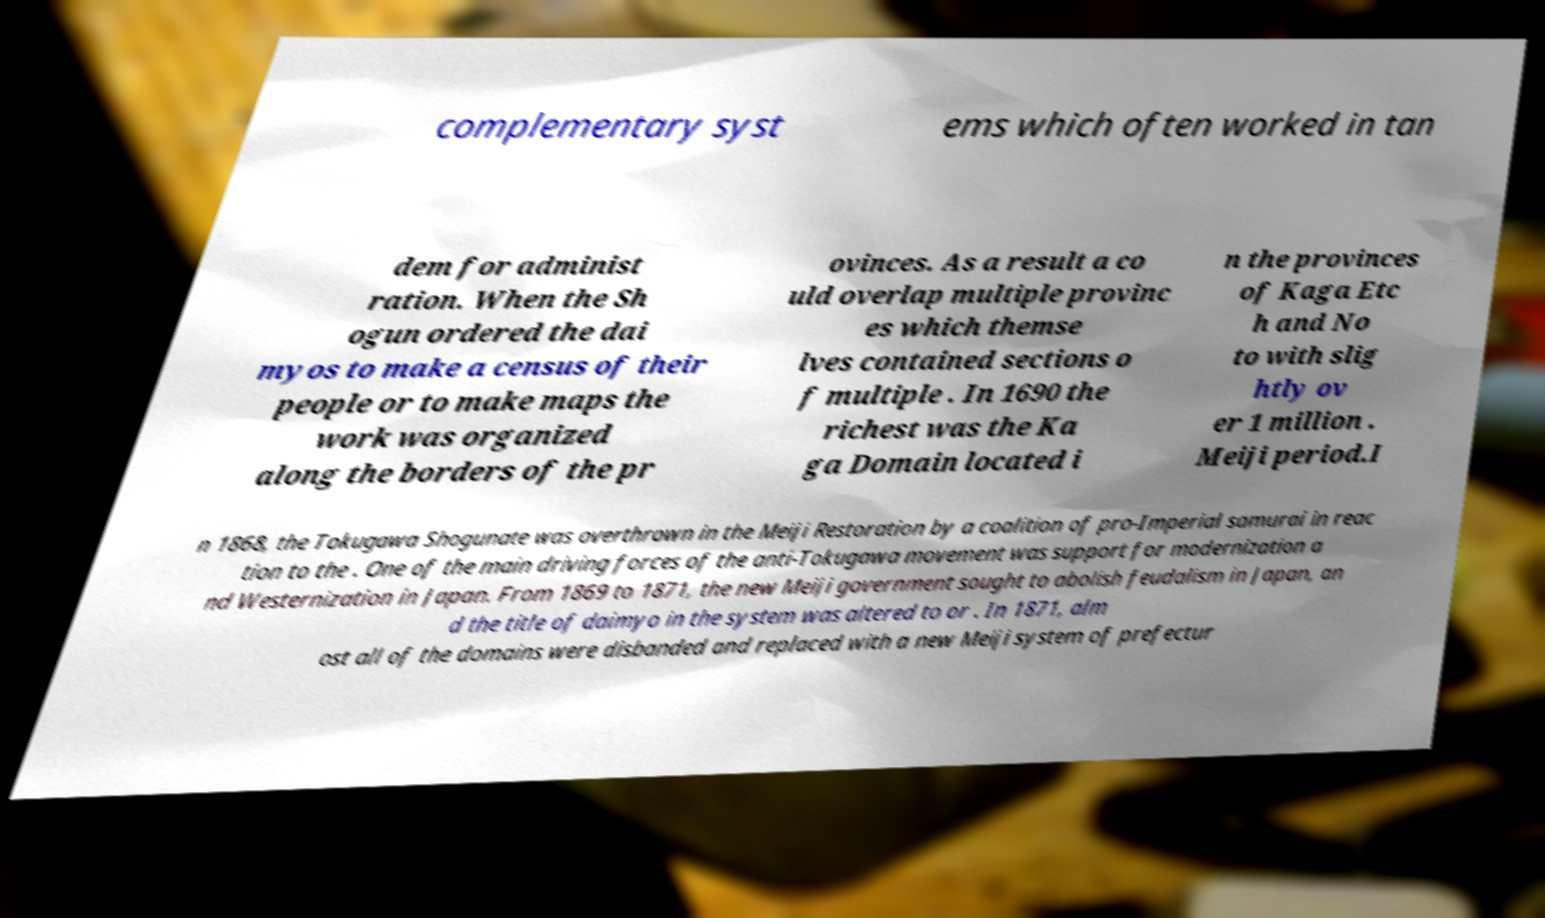Please read and relay the text visible in this image. What does it say? complementary syst ems which often worked in tan dem for administ ration. When the Sh ogun ordered the dai myos to make a census of their people or to make maps the work was organized along the borders of the pr ovinces. As a result a co uld overlap multiple provinc es which themse lves contained sections o f multiple . In 1690 the richest was the Ka ga Domain located i n the provinces of Kaga Etc h and No to with slig htly ov er 1 million . Meiji period.I n 1868, the Tokugawa Shogunate was overthrown in the Meiji Restoration by a coalition of pro-Imperial samurai in reac tion to the . One of the main driving forces of the anti-Tokugawa movement was support for modernization a nd Westernization in Japan. From 1869 to 1871, the new Meiji government sought to abolish feudalism in Japan, an d the title of daimyo in the system was altered to or . In 1871, alm ost all of the domains were disbanded and replaced with a new Meiji system of prefectur 